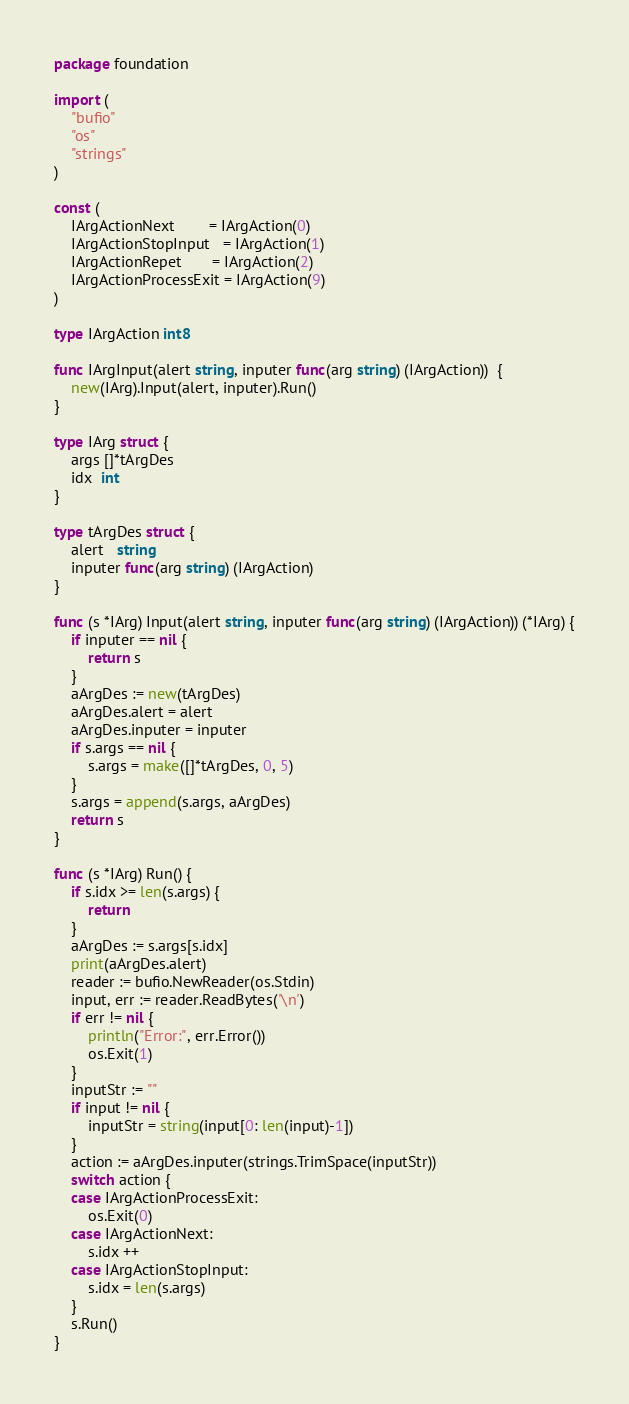<code> <loc_0><loc_0><loc_500><loc_500><_Go_>package foundation

import (
	"bufio"
	"os"
	"strings"
)

const (
	IArgActionNext        = IArgAction(0)
	IArgActionStopInput   = IArgAction(1)
	IArgActionRepet       = IArgAction(2)
	IArgActionProcessExit = IArgAction(9)
)

type IArgAction int8

func IArgInput(alert string, inputer func(arg string) (IArgAction))  {
	new(IArg).Input(alert, inputer).Run()
}

type IArg struct {
	args []*tArgDes
	idx  int
}

type tArgDes struct {
	alert   string
	inputer func(arg string) (IArgAction)
}

func (s *IArg) Input(alert string, inputer func(arg string) (IArgAction)) (*IArg) {
	if inputer == nil {
		return s
	}
	aArgDes := new(tArgDes)
	aArgDes.alert = alert
	aArgDes.inputer = inputer
	if s.args == nil {
		s.args = make([]*tArgDes, 0, 5)
	}
	s.args = append(s.args, aArgDes)
	return s
}

func (s *IArg) Run() {
	if s.idx >= len(s.args) {
		return
	}
	aArgDes := s.args[s.idx]
	print(aArgDes.alert)
	reader := bufio.NewReader(os.Stdin)
	input, err := reader.ReadBytes('\n')
	if err != nil {
		println("Error:", err.Error())
		os.Exit(1)
	}
	inputStr := ""
	if input != nil {
		inputStr = string(input[0: len(input)-1])
	}
	action := aArgDes.inputer(strings.TrimSpace(inputStr))
	switch action {
	case IArgActionProcessExit:
		os.Exit(0)
	case IArgActionNext:
		s.idx ++
	case IArgActionStopInput:
		s.idx = len(s.args)
	}
	s.Run()
}</code> 